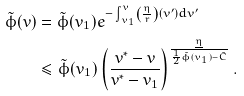<formula> <loc_0><loc_0><loc_500><loc_500>\tilde { \phi } ( v ) & = \tilde { \phi } ( v _ { 1 } ) e ^ { - \int _ { v _ { 1 } } ^ { v } \left ( \frac { \eta } { r } \right ) ( v ^ { \prime } ) d v ^ { \prime } } \\ & \leq \tilde { \phi } ( v _ { 1 } ) \left ( \frac { v ^ { \ast } - v } { v ^ { \ast } - v _ { 1 } } \right ) ^ { \frac { \underline { \eta } } { \frac { 1 } { 2 } \tilde { \phi } ( v _ { 1 } ) - \tilde { C } } } .</formula> 